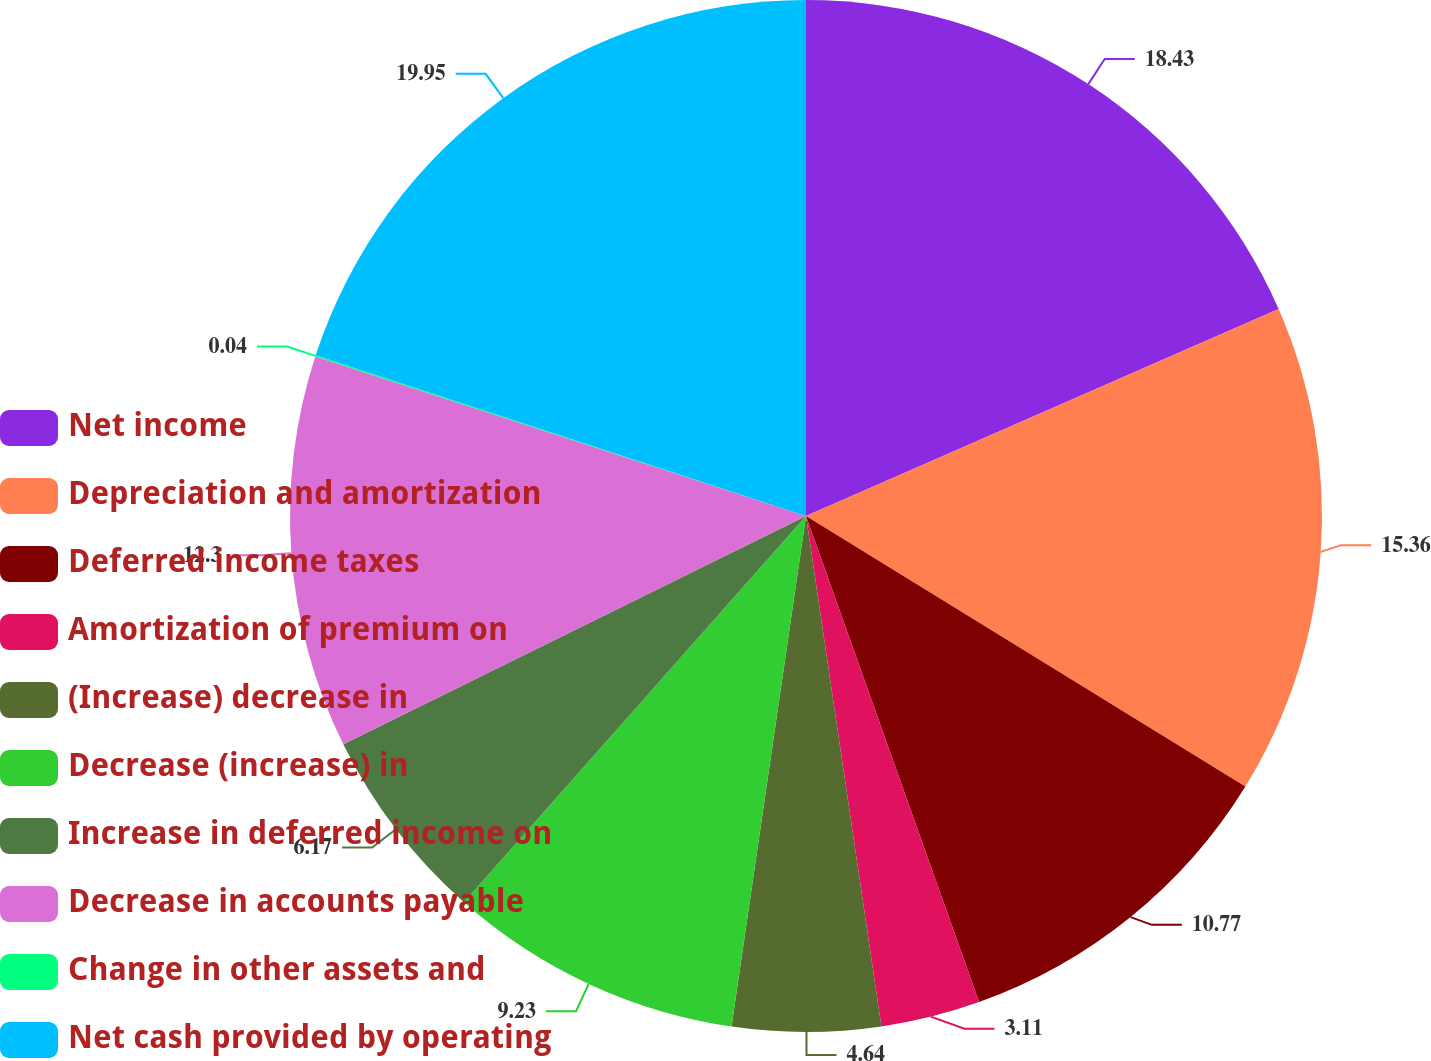<chart> <loc_0><loc_0><loc_500><loc_500><pie_chart><fcel>Net income<fcel>Depreciation and amortization<fcel>Deferred income taxes<fcel>Amortization of premium on<fcel>(Increase) decrease in<fcel>Decrease (increase) in<fcel>Increase in deferred income on<fcel>Decrease in accounts payable<fcel>Change in other assets and<fcel>Net cash provided by operating<nl><fcel>18.43%<fcel>15.36%<fcel>10.77%<fcel>3.11%<fcel>4.64%<fcel>9.23%<fcel>6.17%<fcel>12.3%<fcel>0.04%<fcel>19.96%<nl></chart> 